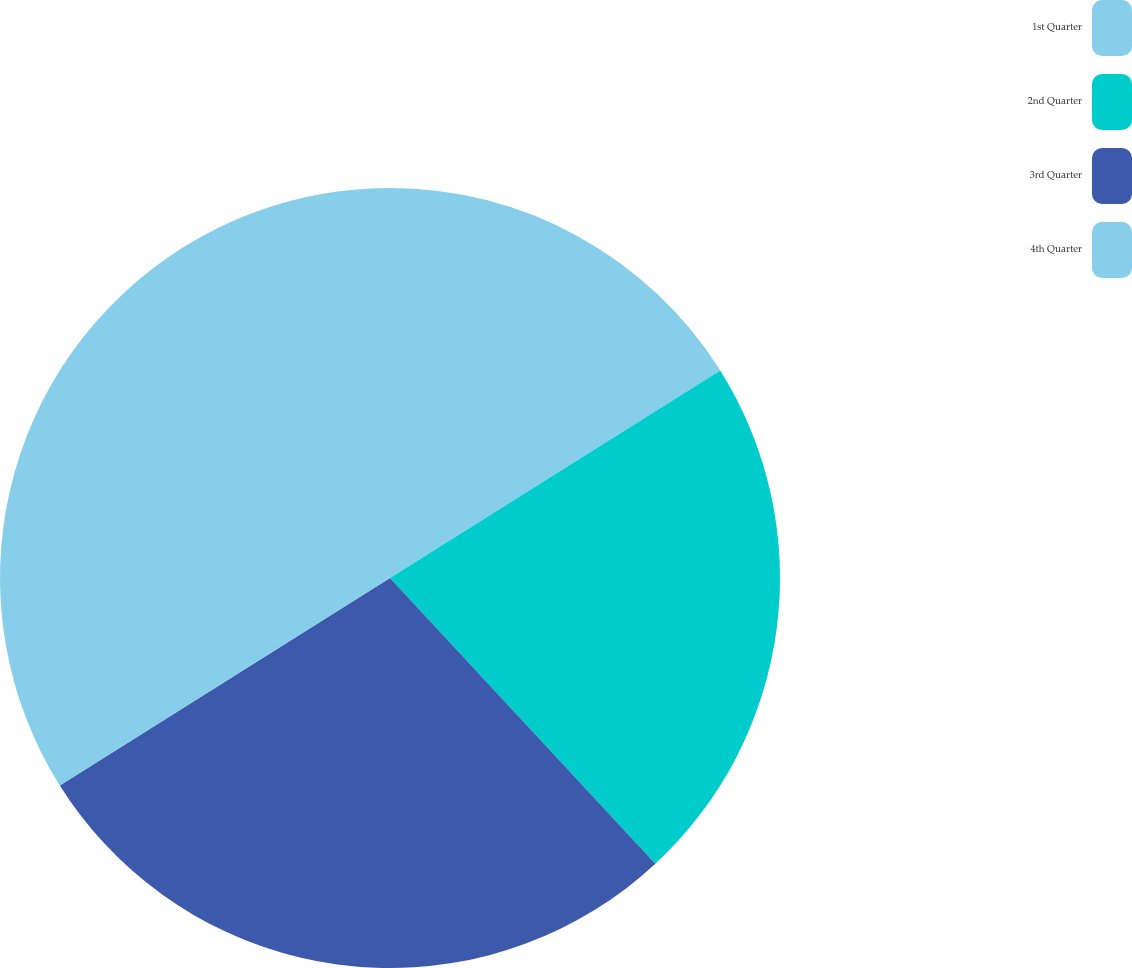Convert chart to OTSL. <chart><loc_0><loc_0><loc_500><loc_500><pie_chart><fcel>1st Quarter<fcel>2nd Quarter<fcel>3rd Quarter<fcel>4th Quarter<nl><fcel>16.07%<fcel>22.02%<fcel>27.98%<fcel>33.93%<nl></chart> 